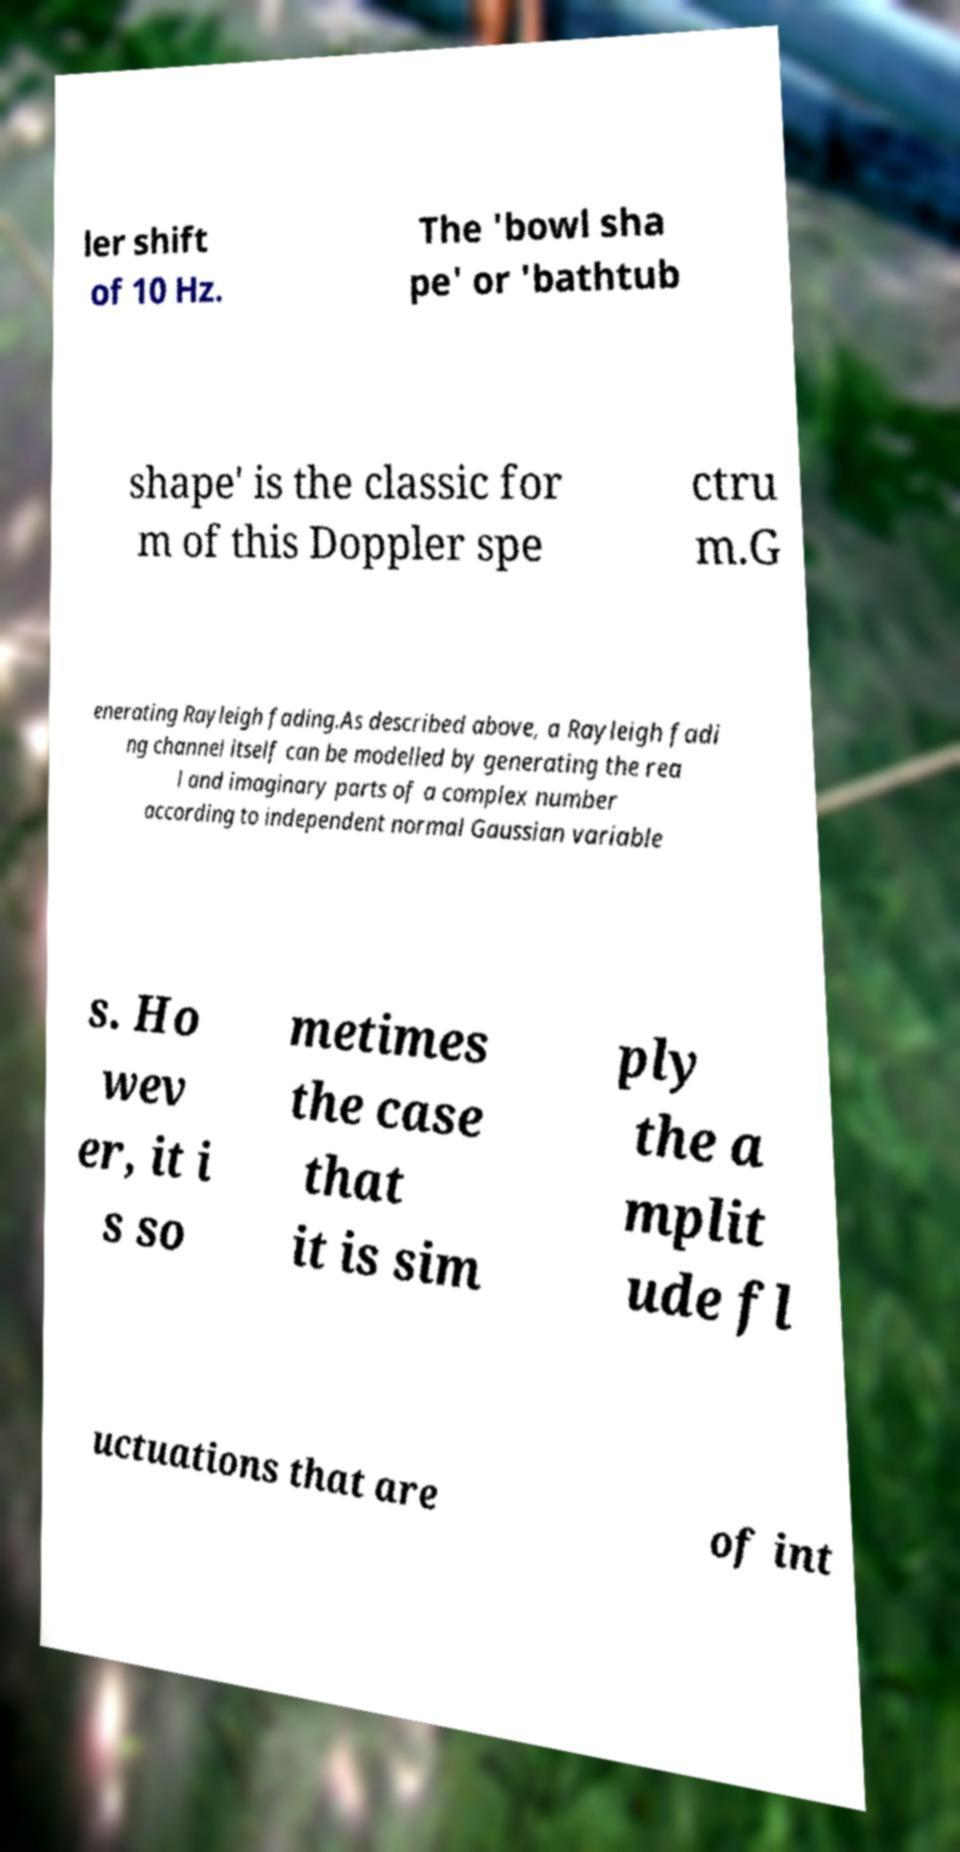Can you read and provide the text displayed in the image?This photo seems to have some interesting text. Can you extract and type it out for me? ler shift of 10 Hz. The 'bowl sha pe' or 'bathtub shape' is the classic for m of this Doppler spe ctru m.G enerating Rayleigh fading.As described above, a Rayleigh fadi ng channel itself can be modelled by generating the rea l and imaginary parts of a complex number according to independent normal Gaussian variable s. Ho wev er, it i s so metimes the case that it is sim ply the a mplit ude fl uctuations that are of int 